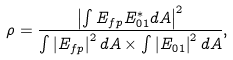<formula> <loc_0><loc_0><loc_500><loc_500>\rho = \frac { \left | \int E _ { f p } E ^ { * } _ { 0 1 } d A \right | ^ { 2 } } { \int \left | E _ { f p } \right | ^ { 2 } d A \times \int \left | E _ { 0 1 } \right | ^ { 2 } d A } ,</formula> 